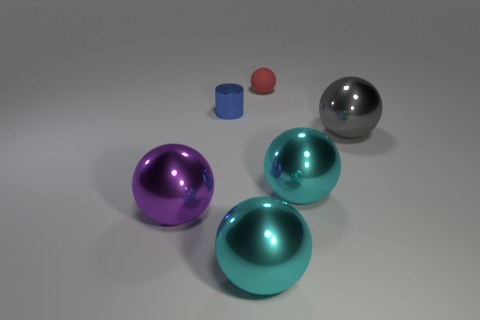Subtract 2 balls. How many balls are left? 3 Subtract all tiny balls. How many balls are left? 4 Subtract all gray spheres. How many spheres are left? 4 Subtract all green balls. Subtract all cyan cubes. How many balls are left? 5 Add 1 gray objects. How many objects exist? 7 Subtract all balls. How many objects are left? 1 Subtract all large yellow balls. Subtract all tiny red matte objects. How many objects are left? 5 Add 4 small red things. How many small red things are left? 5 Add 1 cyan balls. How many cyan balls exist? 3 Subtract 0 green cubes. How many objects are left? 6 